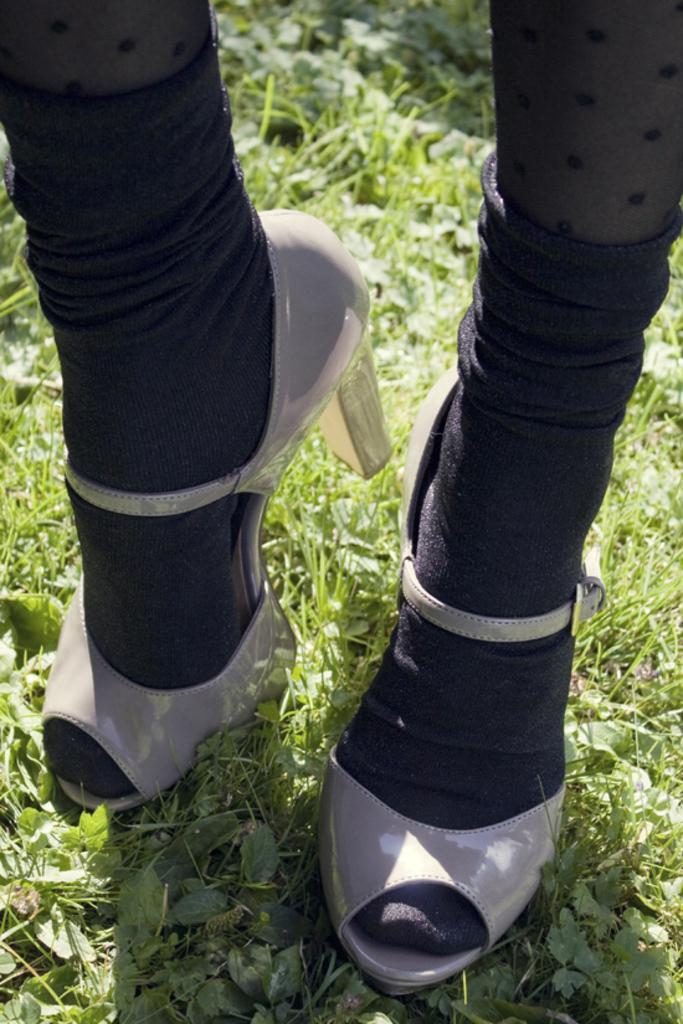What body parts are visible in the picture? There are women's legs in the picture. What type of footwear are the women wearing? The women are wearing sandals. What color are the socks the women are wearing? The women are wearing black socks. What type of terrain is visible at the bottom of the picture? There is grass visible at the bottom of the picture. What is the weather like on the day the picture was taken? It is a sunny day. Where is the sofa located in the picture? There is no sofa present in the picture. How many legs does the body have in the picture? The picture only shows women's legs, and it is not possible to determine the number of legs a body has from the image. 